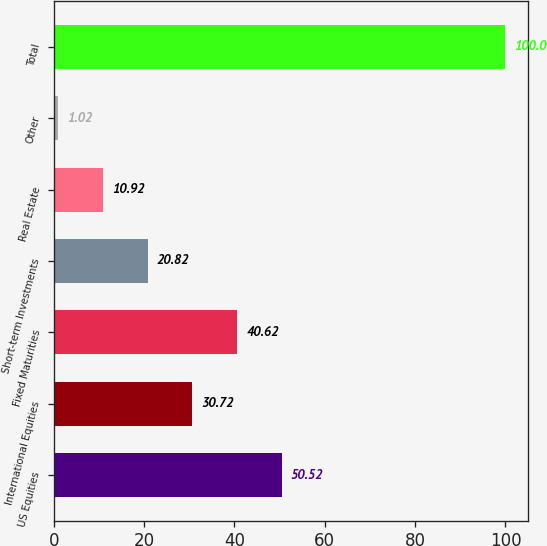Convert chart to OTSL. <chart><loc_0><loc_0><loc_500><loc_500><bar_chart><fcel>US Equities<fcel>International Equities<fcel>Fixed Maturities<fcel>Short-term Investments<fcel>Real Estate<fcel>Other<fcel>Total<nl><fcel>50.52<fcel>30.72<fcel>40.62<fcel>20.82<fcel>10.92<fcel>1.02<fcel>100<nl></chart> 